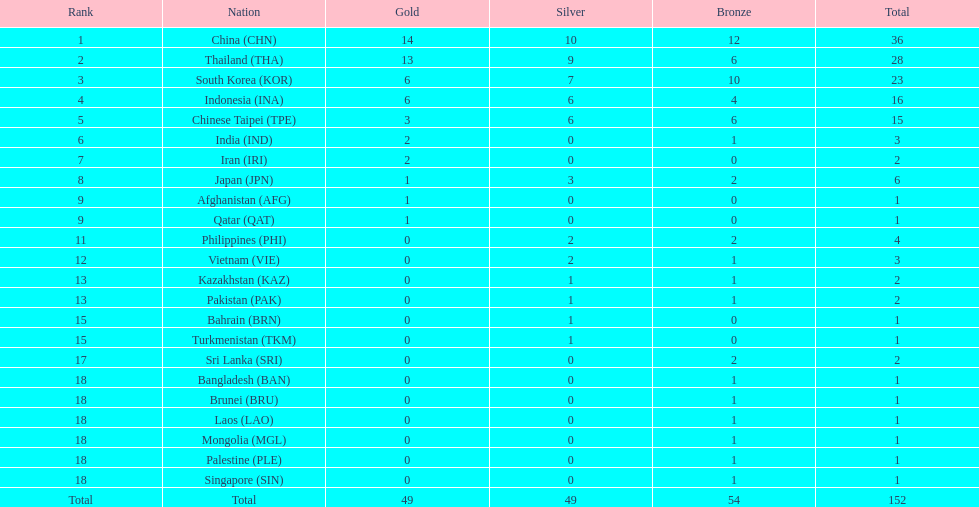What is the total number of nations that participated in the beach games of 2012? 23. 